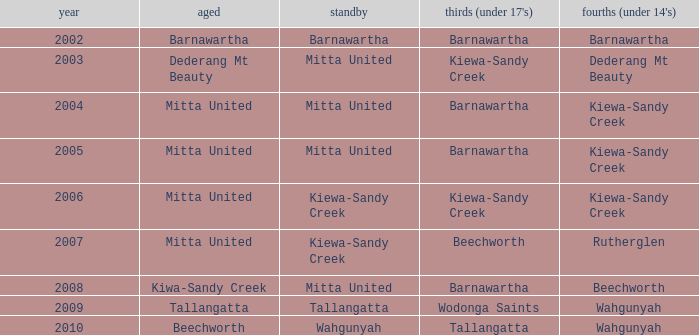Which seniors hold year pre-2006, and fourths (under 14's) of kiewa-sandy creek? Mitta United, Mitta United. 